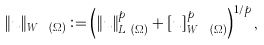Convert formula to latex. <formula><loc_0><loc_0><loc_500><loc_500>\| u \| _ { W ^ { s , p } ( \Omega ) } \vcentcolon = \left ( \| u \| _ { L ^ { p } ( \Omega ) } ^ { p } + [ u ] _ { W ^ { s , p } ( \Omega ) } ^ { p } \right ) ^ { 1 / p } ,</formula> 